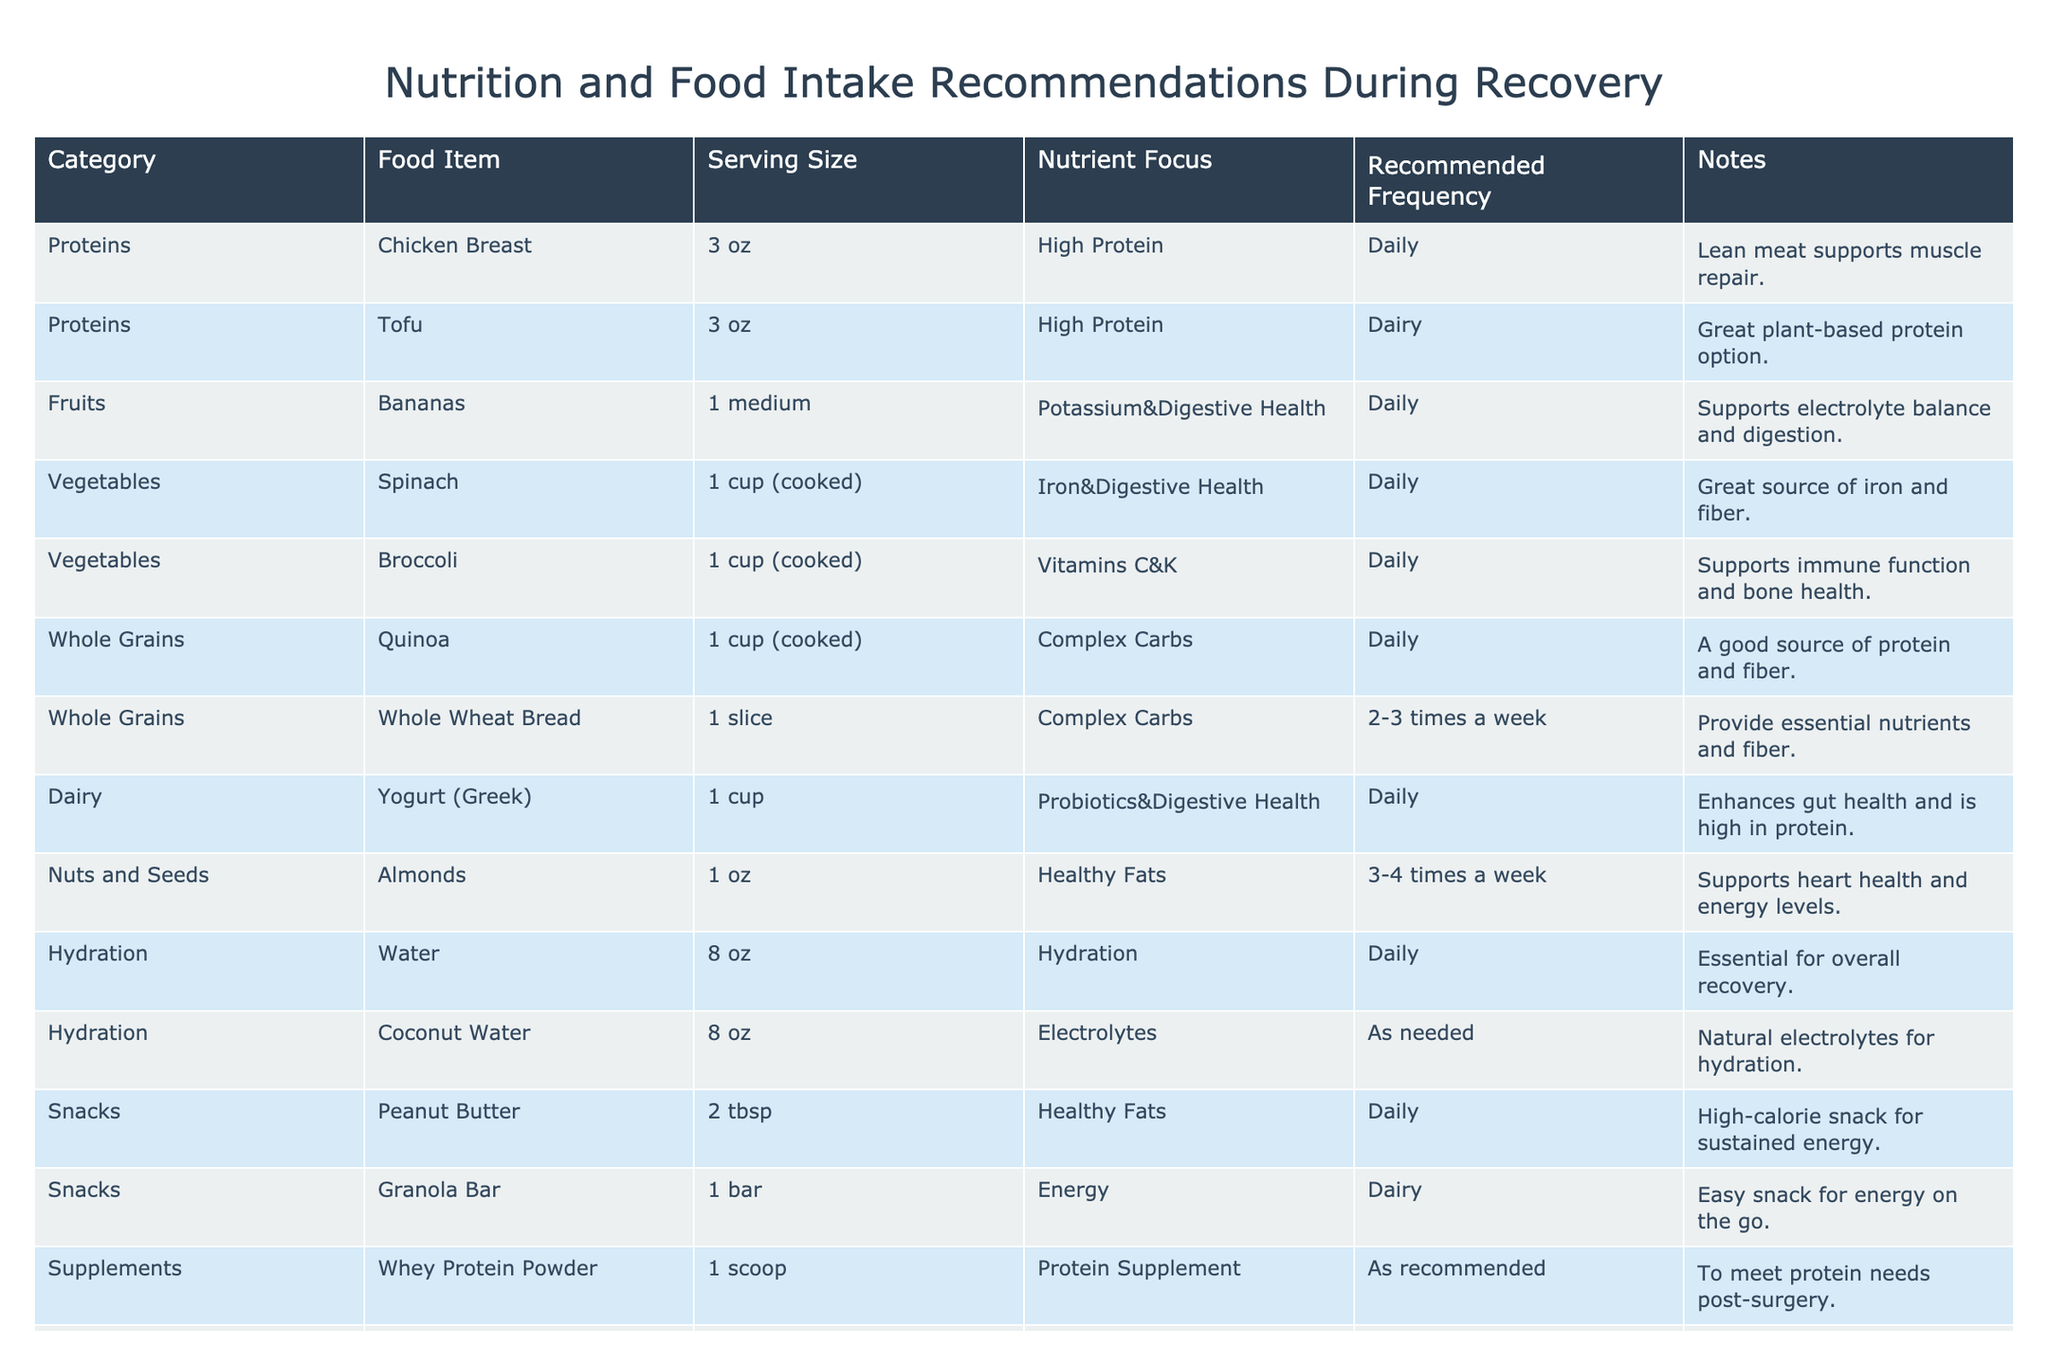What is the recommended serving size for chicken breast? The table lists the serving size for chicken breast as 3 oz.
Answer: 3 oz How often should spinach be consumed during recovery? The table indicates that spinach should be consumed daily.
Answer: Daily Is yogurt recommended for daily intake? The table states that yogurt (Greek) should be consumed daily.
Answer: Yes Which food item is suggested as a great plant-based protein option? The table mentions tofu as a great plant-based protein option.
Answer: Tofu What nutrient focus is associated with bananas? According to the table, bananas focus on potassium and digestive health.
Answer: Potassium and Digestive Health How many times a week should almonds be eaten? The table advises eating almonds 3-4 times a week.
Answer: 3-4 times a week Is coconut water listed as a daily hydration option? The table specifies that coconut water is to be consumed as needed, not daily.
Answer: No What is the main nutrient focus of quinoa? The table indicates that quinoa focuses on complex carbs.
Answer: Complex Carbs How much yogurt is recommended for a serving? The table specifies a serving size of 1 cup for yogurt (Greek).
Answer: 1 cup What is the recommended frequency of whey protein powder intake? The table states that whey protein powder should be taken as recommended, which may vary.
Answer: As recommended Which food item supports heart health and is considered a healthy fat? The table lists almonds as the food item that supports heart health.
Answer: Almonds If a person consumes whole wheat bread 2 times a week and spinach daily, how many total servings of these two items will they consume in a week? Whole wheat bread is consumed 2-3 times a week (let's say 2 for this calculation), and spinach is consumed daily (7 times). Therefore, 2 (whole wheat bread) + 7 (spinach) = 9 total servings in a week.
Answer: 9 Which food item should be consumed as needed for hydration? The table states that coconut water should be consumed as needed.
Answer: Coconut Water If someone eats chicken breast daily and yogurt daily, how many servings of chicken breast and yogurt will they consume in a week? Chicken breast is eaten daily (7 servings), and yogurt is also eaten daily (7 servings), giving a total of 7 (chicken) + 7 (yogurt) = 14 servings in a week.
Answer: 14 Is peanut butter recommended for daily intake? The table specifies that peanut butter is recommended for daily consumption.
Answer: Yes What is the relationship of broccoli regarding health according to the recommendations? The table indicates that broccoli supports immune function and bone health.
Answer: Immune function and bone health 